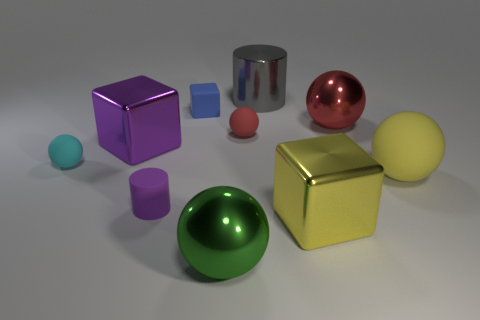Subtract all red rubber balls. How many balls are left? 4 Subtract all cyan balls. How many balls are left? 4 Subtract 1 cubes. How many cubes are left? 2 Subtract all cyan cylinders. How many green spheres are left? 1 Add 10 green rubber balls. How many green rubber balls exist? 10 Subtract 0 brown balls. How many objects are left? 10 Subtract all cylinders. How many objects are left? 8 Subtract all red cylinders. Subtract all gray cubes. How many cylinders are left? 2 Subtract all cyan shiny blocks. Subtract all small rubber things. How many objects are left? 6 Add 2 big blocks. How many big blocks are left? 4 